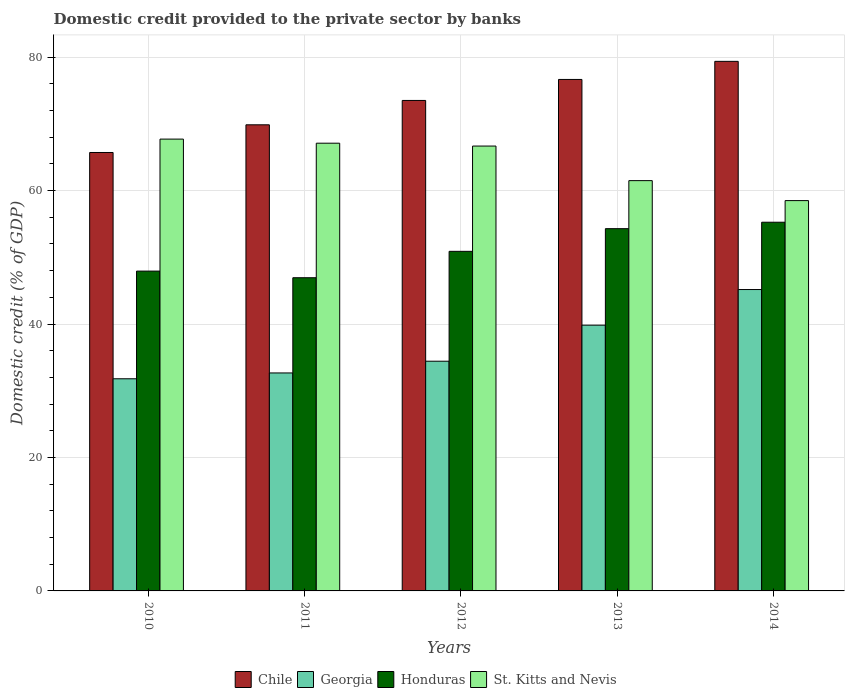How many different coloured bars are there?
Give a very brief answer. 4. How many groups of bars are there?
Ensure brevity in your answer.  5. Are the number of bars on each tick of the X-axis equal?
Ensure brevity in your answer.  Yes. How many bars are there on the 4th tick from the left?
Give a very brief answer. 4. How many bars are there on the 3rd tick from the right?
Keep it short and to the point. 4. In how many cases, is the number of bars for a given year not equal to the number of legend labels?
Offer a very short reply. 0. What is the domestic credit provided to the private sector by banks in Chile in 2012?
Offer a very short reply. 73.51. Across all years, what is the maximum domestic credit provided to the private sector by banks in Chile?
Provide a succinct answer. 79.37. Across all years, what is the minimum domestic credit provided to the private sector by banks in St. Kitts and Nevis?
Offer a terse response. 58.5. In which year was the domestic credit provided to the private sector by banks in Honduras maximum?
Make the answer very short. 2014. What is the total domestic credit provided to the private sector by banks in Chile in the graph?
Your response must be concise. 365.12. What is the difference between the domestic credit provided to the private sector by banks in Honduras in 2011 and that in 2013?
Give a very brief answer. -7.36. What is the difference between the domestic credit provided to the private sector by banks in Chile in 2011 and the domestic credit provided to the private sector by banks in Honduras in 2010?
Provide a short and direct response. 21.93. What is the average domestic credit provided to the private sector by banks in St. Kitts and Nevis per year?
Provide a succinct answer. 64.3. In the year 2013, what is the difference between the domestic credit provided to the private sector by banks in St. Kitts and Nevis and domestic credit provided to the private sector by banks in Chile?
Offer a terse response. -15.17. In how many years, is the domestic credit provided to the private sector by banks in Chile greater than 72 %?
Your answer should be compact. 3. What is the ratio of the domestic credit provided to the private sector by banks in Honduras in 2011 to that in 2012?
Your answer should be compact. 0.92. Is the domestic credit provided to the private sector by banks in St. Kitts and Nevis in 2010 less than that in 2012?
Your response must be concise. No. Is the difference between the domestic credit provided to the private sector by banks in St. Kitts and Nevis in 2011 and 2014 greater than the difference between the domestic credit provided to the private sector by banks in Chile in 2011 and 2014?
Make the answer very short. Yes. What is the difference between the highest and the second highest domestic credit provided to the private sector by banks in Georgia?
Your answer should be very brief. 5.34. What is the difference between the highest and the lowest domestic credit provided to the private sector by banks in Chile?
Provide a succinct answer. 13.66. Is it the case that in every year, the sum of the domestic credit provided to the private sector by banks in St. Kitts and Nevis and domestic credit provided to the private sector by banks in Georgia is greater than the sum of domestic credit provided to the private sector by banks in Honduras and domestic credit provided to the private sector by banks in Chile?
Ensure brevity in your answer.  No. What does the 4th bar from the left in 2014 represents?
Offer a very short reply. St. Kitts and Nevis. What does the 1st bar from the right in 2011 represents?
Keep it short and to the point. St. Kitts and Nevis. Is it the case that in every year, the sum of the domestic credit provided to the private sector by banks in Georgia and domestic credit provided to the private sector by banks in Honduras is greater than the domestic credit provided to the private sector by banks in St. Kitts and Nevis?
Ensure brevity in your answer.  Yes. How many bars are there?
Make the answer very short. 20. How many years are there in the graph?
Provide a short and direct response. 5. Does the graph contain any zero values?
Offer a terse response. No. What is the title of the graph?
Provide a short and direct response. Domestic credit provided to the private sector by banks. Does "Central African Republic" appear as one of the legend labels in the graph?
Provide a succinct answer. No. What is the label or title of the Y-axis?
Keep it short and to the point. Domestic credit (% of GDP). What is the Domestic credit (% of GDP) in Chile in 2010?
Give a very brief answer. 65.71. What is the Domestic credit (% of GDP) in Georgia in 2010?
Provide a succinct answer. 31.8. What is the Domestic credit (% of GDP) of Honduras in 2010?
Ensure brevity in your answer.  47.93. What is the Domestic credit (% of GDP) of St. Kitts and Nevis in 2010?
Your answer should be very brief. 67.72. What is the Domestic credit (% of GDP) in Chile in 2011?
Keep it short and to the point. 69.86. What is the Domestic credit (% of GDP) of Georgia in 2011?
Provide a short and direct response. 32.67. What is the Domestic credit (% of GDP) in Honduras in 2011?
Provide a succinct answer. 46.94. What is the Domestic credit (% of GDP) of St. Kitts and Nevis in 2011?
Ensure brevity in your answer.  67.1. What is the Domestic credit (% of GDP) of Chile in 2012?
Offer a very short reply. 73.51. What is the Domestic credit (% of GDP) in Georgia in 2012?
Your answer should be compact. 34.43. What is the Domestic credit (% of GDP) of Honduras in 2012?
Offer a very short reply. 50.9. What is the Domestic credit (% of GDP) of St. Kitts and Nevis in 2012?
Offer a very short reply. 66.68. What is the Domestic credit (% of GDP) of Chile in 2013?
Your answer should be very brief. 76.66. What is the Domestic credit (% of GDP) in Georgia in 2013?
Provide a succinct answer. 39.83. What is the Domestic credit (% of GDP) in Honduras in 2013?
Ensure brevity in your answer.  54.3. What is the Domestic credit (% of GDP) in St. Kitts and Nevis in 2013?
Provide a succinct answer. 61.49. What is the Domestic credit (% of GDP) in Chile in 2014?
Offer a terse response. 79.37. What is the Domestic credit (% of GDP) of Georgia in 2014?
Ensure brevity in your answer.  45.17. What is the Domestic credit (% of GDP) of Honduras in 2014?
Give a very brief answer. 55.26. What is the Domestic credit (% of GDP) in St. Kitts and Nevis in 2014?
Your answer should be compact. 58.5. Across all years, what is the maximum Domestic credit (% of GDP) in Chile?
Provide a short and direct response. 79.37. Across all years, what is the maximum Domestic credit (% of GDP) of Georgia?
Keep it short and to the point. 45.17. Across all years, what is the maximum Domestic credit (% of GDP) in Honduras?
Your answer should be compact. 55.26. Across all years, what is the maximum Domestic credit (% of GDP) of St. Kitts and Nevis?
Provide a short and direct response. 67.72. Across all years, what is the minimum Domestic credit (% of GDP) in Chile?
Provide a short and direct response. 65.71. Across all years, what is the minimum Domestic credit (% of GDP) of Georgia?
Provide a succinct answer. 31.8. Across all years, what is the minimum Domestic credit (% of GDP) in Honduras?
Your response must be concise. 46.94. Across all years, what is the minimum Domestic credit (% of GDP) in St. Kitts and Nevis?
Your answer should be very brief. 58.5. What is the total Domestic credit (% of GDP) of Chile in the graph?
Ensure brevity in your answer.  365.12. What is the total Domestic credit (% of GDP) in Georgia in the graph?
Keep it short and to the point. 183.9. What is the total Domestic credit (% of GDP) of Honduras in the graph?
Give a very brief answer. 255.33. What is the total Domestic credit (% of GDP) in St. Kitts and Nevis in the graph?
Give a very brief answer. 321.49. What is the difference between the Domestic credit (% of GDP) in Chile in 2010 and that in 2011?
Your answer should be very brief. -4.15. What is the difference between the Domestic credit (% of GDP) of Georgia in 2010 and that in 2011?
Make the answer very short. -0.87. What is the difference between the Domestic credit (% of GDP) of St. Kitts and Nevis in 2010 and that in 2011?
Your answer should be very brief. 0.61. What is the difference between the Domestic credit (% of GDP) in Chile in 2010 and that in 2012?
Ensure brevity in your answer.  -7.8. What is the difference between the Domestic credit (% of GDP) in Georgia in 2010 and that in 2012?
Your answer should be very brief. -2.63. What is the difference between the Domestic credit (% of GDP) in Honduras in 2010 and that in 2012?
Offer a terse response. -2.96. What is the difference between the Domestic credit (% of GDP) of St. Kitts and Nevis in 2010 and that in 2012?
Offer a terse response. 1.04. What is the difference between the Domestic credit (% of GDP) of Chile in 2010 and that in 2013?
Keep it short and to the point. -10.95. What is the difference between the Domestic credit (% of GDP) of Georgia in 2010 and that in 2013?
Your answer should be very brief. -8.04. What is the difference between the Domestic credit (% of GDP) of Honduras in 2010 and that in 2013?
Make the answer very short. -6.36. What is the difference between the Domestic credit (% of GDP) of St. Kitts and Nevis in 2010 and that in 2013?
Offer a very short reply. 6.22. What is the difference between the Domestic credit (% of GDP) in Chile in 2010 and that in 2014?
Offer a terse response. -13.66. What is the difference between the Domestic credit (% of GDP) in Georgia in 2010 and that in 2014?
Your response must be concise. -13.37. What is the difference between the Domestic credit (% of GDP) of Honduras in 2010 and that in 2014?
Provide a succinct answer. -7.33. What is the difference between the Domestic credit (% of GDP) of St. Kitts and Nevis in 2010 and that in 2014?
Your response must be concise. 9.22. What is the difference between the Domestic credit (% of GDP) of Chile in 2011 and that in 2012?
Provide a short and direct response. -3.65. What is the difference between the Domestic credit (% of GDP) of Georgia in 2011 and that in 2012?
Your answer should be compact. -1.76. What is the difference between the Domestic credit (% of GDP) in Honduras in 2011 and that in 2012?
Provide a succinct answer. -3.96. What is the difference between the Domestic credit (% of GDP) of St. Kitts and Nevis in 2011 and that in 2012?
Ensure brevity in your answer.  0.43. What is the difference between the Domestic credit (% of GDP) in Chile in 2011 and that in 2013?
Offer a very short reply. -6.8. What is the difference between the Domestic credit (% of GDP) in Georgia in 2011 and that in 2013?
Keep it short and to the point. -7.16. What is the difference between the Domestic credit (% of GDP) in Honduras in 2011 and that in 2013?
Your answer should be compact. -7.36. What is the difference between the Domestic credit (% of GDP) of St. Kitts and Nevis in 2011 and that in 2013?
Make the answer very short. 5.61. What is the difference between the Domestic credit (% of GDP) of Chile in 2011 and that in 2014?
Offer a very short reply. -9.51. What is the difference between the Domestic credit (% of GDP) of Georgia in 2011 and that in 2014?
Make the answer very short. -12.5. What is the difference between the Domestic credit (% of GDP) of Honduras in 2011 and that in 2014?
Make the answer very short. -8.32. What is the difference between the Domestic credit (% of GDP) of St. Kitts and Nevis in 2011 and that in 2014?
Your answer should be very brief. 8.6. What is the difference between the Domestic credit (% of GDP) of Chile in 2012 and that in 2013?
Your response must be concise. -3.15. What is the difference between the Domestic credit (% of GDP) in Georgia in 2012 and that in 2013?
Your response must be concise. -5.4. What is the difference between the Domestic credit (% of GDP) of Honduras in 2012 and that in 2013?
Offer a very short reply. -3.4. What is the difference between the Domestic credit (% of GDP) in St. Kitts and Nevis in 2012 and that in 2013?
Give a very brief answer. 5.18. What is the difference between the Domestic credit (% of GDP) of Chile in 2012 and that in 2014?
Your answer should be compact. -5.86. What is the difference between the Domestic credit (% of GDP) of Georgia in 2012 and that in 2014?
Keep it short and to the point. -10.74. What is the difference between the Domestic credit (% of GDP) in Honduras in 2012 and that in 2014?
Offer a very short reply. -4.36. What is the difference between the Domestic credit (% of GDP) in St. Kitts and Nevis in 2012 and that in 2014?
Provide a short and direct response. 8.18. What is the difference between the Domestic credit (% of GDP) of Chile in 2013 and that in 2014?
Your response must be concise. -2.71. What is the difference between the Domestic credit (% of GDP) of Georgia in 2013 and that in 2014?
Offer a very short reply. -5.34. What is the difference between the Domestic credit (% of GDP) in Honduras in 2013 and that in 2014?
Your answer should be very brief. -0.96. What is the difference between the Domestic credit (% of GDP) of St. Kitts and Nevis in 2013 and that in 2014?
Keep it short and to the point. 2.99. What is the difference between the Domestic credit (% of GDP) in Chile in 2010 and the Domestic credit (% of GDP) in Georgia in 2011?
Ensure brevity in your answer.  33.04. What is the difference between the Domestic credit (% of GDP) in Chile in 2010 and the Domestic credit (% of GDP) in Honduras in 2011?
Offer a very short reply. 18.77. What is the difference between the Domestic credit (% of GDP) in Chile in 2010 and the Domestic credit (% of GDP) in St. Kitts and Nevis in 2011?
Ensure brevity in your answer.  -1.39. What is the difference between the Domestic credit (% of GDP) in Georgia in 2010 and the Domestic credit (% of GDP) in Honduras in 2011?
Offer a terse response. -15.14. What is the difference between the Domestic credit (% of GDP) in Georgia in 2010 and the Domestic credit (% of GDP) in St. Kitts and Nevis in 2011?
Your response must be concise. -35.31. What is the difference between the Domestic credit (% of GDP) in Honduras in 2010 and the Domestic credit (% of GDP) in St. Kitts and Nevis in 2011?
Make the answer very short. -19.17. What is the difference between the Domestic credit (% of GDP) of Chile in 2010 and the Domestic credit (% of GDP) of Georgia in 2012?
Offer a terse response. 31.28. What is the difference between the Domestic credit (% of GDP) of Chile in 2010 and the Domestic credit (% of GDP) of Honduras in 2012?
Provide a short and direct response. 14.81. What is the difference between the Domestic credit (% of GDP) of Chile in 2010 and the Domestic credit (% of GDP) of St. Kitts and Nevis in 2012?
Ensure brevity in your answer.  -0.96. What is the difference between the Domestic credit (% of GDP) of Georgia in 2010 and the Domestic credit (% of GDP) of Honduras in 2012?
Keep it short and to the point. -19.1. What is the difference between the Domestic credit (% of GDP) in Georgia in 2010 and the Domestic credit (% of GDP) in St. Kitts and Nevis in 2012?
Keep it short and to the point. -34.88. What is the difference between the Domestic credit (% of GDP) in Honduras in 2010 and the Domestic credit (% of GDP) in St. Kitts and Nevis in 2012?
Keep it short and to the point. -18.74. What is the difference between the Domestic credit (% of GDP) in Chile in 2010 and the Domestic credit (% of GDP) in Georgia in 2013?
Your answer should be compact. 25.88. What is the difference between the Domestic credit (% of GDP) of Chile in 2010 and the Domestic credit (% of GDP) of Honduras in 2013?
Your answer should be compact. 11.42. What is the difference between the Domestic credit (% of GDP) in Chile in 2010 and the Domestic credit (% of GDP) in St. Kitts and Nevis in 2013?
Offer a terse response. 4.22. What is the difference between the Domestic credit (% of GDP) of Georgia in 2010 and the Domestic credit (% of GDP) of Honduras in 2013?
Offer a terse response. -22.5. What is the difference between the Domestic credit (% of GDP) in Georgia in 2010 and the Domestic credit (% of GDP) in St. Kitts and Nevis in 2013?
Make the answer very short. -29.7. What is the difference between the Domestic credit (% of GDP) of Honduras in 2010 and the Domestic credit (% of GDP) of St. Kitts and Nevis in 2013?
Offer a very short reply. -13.56. What is the difference between the Domestic credit (% of GDP) in Chile in 2010 and the Domestic credit (% of GDP) in Georgia in 2014?
Ensure brevity in your answer.  20.54. What is the difference between the Domestic credit (% of GDP) in Chile in 2010 and the Domestic credit (% of GDP) in Honduras in 2014?
Offer a terse response. 10.45. What is the difference between the Domestic credit (% of GDP) in Chile in 2010 and the Domestic credit (% of GDP) in St. Kitts and Nevis in 2014?
Ensure brevity in your answer.  7.21. What is the difference between the Domestic credit (% of GDP) of Georgia in 2010 and the Domestic credit (% of GDP) of Honduras in 2014?
Your answer should be very brief. -23.46. What is the difference between the Domestic credit (% of GDP) of Georgia in 2010 and the Domestic credit (% of GDP) of St. Kitts and Nevis in 2014?
Offer a very short reply. -26.7. What is the difference between the Domestic credit (% of GDP) in Honduras in 2010 and the Domestic credit (% of GDP) in St. Kitts and Nevis in 2014?
Offer a very short reply. -10.57. What is the difference between the Domestic credit (% of GDP) in Chile in 2011 and the Domestic credit (% of GDP) in Georgia in 2012?
Make the answer very short. 35.43. What is the difference between the Domestic credit (% of GDP) in Chile in 2011 and the Domestic credit (% of GDP) in Honduras in 2012?
Give a very brief answer. 18.96. What is the difference between the Domestic credit (% of GDP) of Chile in 2011 and the Domestic credit (% of GDP) of St. Kitts and Nevis in 2012?
Provide a succinct answer. 3.19. What is the difference between the Domestic credit (% of GDP) in Georgia in 2011 and the Domestic credit (% of GDP) in Honduras in 2012?
Offer a very short reply. -18.23. What is the difference between the Domestic credit (% of GDP) in Georgia in 2011 and the Domestic credit (% of GDP) in St. Kitts and Nevis in 2012?
Make the answer very short. -34.01. What is the difference between the Domestic credit (% of GDP) in Honduras in 2011 and the Domestic credit (% of GDP) in St. Kitts and Nevis in 2012?
Your answer should be very brief. -19.74. What is the difference between the Domestic credit (% of GDP) in Chile in 2011 and the Domestic credit (% of GDP) in Georgia in 2013?
Offer a terse response. 30.03. What is the difference between the Domestic credit (% of GDP) in Chile in 2011 and the Domestic credit (% of GDP) in Honduras in 2013?
Provide a short and direct response. 15.57. What is the difference between the Domestic credit (% of GDP) in Chile in 2011 and the Domestic credit (% of GDP) in St. Kitts and Nevis in 2013?
Provide a succinct answer. 8.37. What is the difference between the Domestic credit (% of GDP) of Georgia in 2011 and the Domestic credit (% of GDP) of Honduras in 2013?
Keep it short and to the point. -21.62. What is the difference between the Domestic credit (% of GDP) in Georgia in 2011 and the Domestic credit (% of GDP) in St. Kitts and Nevis in 2013?
Your answer should be compact. -28.82. What is the difference between the Domestic credit (% of GDP) of Honduras in 2011 and the Domestic credit (% of GDP) of St. Kitts and Nevis in 2013?
Your response must be concise. -14.55. What is the difference between the Domestic credit (% of GDP) of Chile in 2011 and the Domestic credit (% of GDP) of Georgia in 2014?
Keep it short and to the point. 24.69. What is the difference between the Domestic credit (% of GDP) in Chile in 2011 and the Domestic credit (% of GDP) in Honduras in 2014?
Ensure brevity in your answer.  14.6. What is the difference between the Domestic credit (% of GDP) in Chile in 2011 and the Domestic credit (% of GDP) in St. Kitts and Nevis in 2014?
Make the answer very short. 11.36. What is the difference between the Domestic credit (% of GDP) of Georgia in 2011 and the Domestic credit (% of GDP) of Honduras in 2014?
Your response must be concise. -22.59. What is the difference between the Domestic credit (% of GDP) in Georgia in 2011 and the Domestic credit (% of GDP) in St. Kitts and Nevis in 2014?
Offer a terse response. -25.83. What is the difference between the Domestic credit (% of GDP) in Honduras in 2011 and the Domestic credit (% of GDP) in St. Kitts and Nevis in 2014?
Ensure brevity in your answer.  -11.56. What is the difference between the Domestic credit (% of GDP) of Chile in 2012 and the Domestic credit (% of GDP) of Georgia in 2013?
Keep it short and to the point. 33.68. What is the difference between the Domestic credit (% of GDP) in Chile in 2012 and the Domestic credit (% of GDP) in Honduras in 2013?
Provide a short and direct response. 19.22. What is the difference between the Domestic credit (% of GDP) in Chile in 2012 and the Domestic credit (% of GDP) in St. Kitts and Nevis in 2013?
Make the answer very short. 12.02. What is the difference between the Domestic credit (% of GDP) of Georgia in 2012 and the Domestic credit (% of GDP) of Honduras in 2013?
Ensure brevity in your answer.  -19.87. What is the difference between the Domestic credit (% of GDP) in Georgia in 2012 and the Domestic credit (% of GDP) in St. Kitts and Nevis in 2013?
Keep it short and to the point. -27.06. What is the difference between the Domestic credit (% of GDP) in Honduras in 2012 and the Domestic credit (% of GDP) in St. Kitts and Nevis in 2013?
Keep it short and to the point. -10.6. What is the difference between the Domestic credit (% of GDP) in Chile in 2012 and the Domestic credit (% of GDP) in Georgia in 2014?
Make the answer very short. 28.34. What is the difference between the Domestic credit (% of GDP) of Chile in 2012 and the Domestic credit (% of GDP) of Honduras in 2014?
Your response must be concise. 18.25. What is the difference between the Domestic credit (% of GDP) of Chile in 2012 and the Domestic credit (% of GDP) of St. Kitts and Nevis in 2014?
Keep it short and to the point. 15.01. What is the difference between the Domestic credit (% of GDP) in Georgia in 2012 and the Domestic credit (% of GDP) in Honduras in 2014?
Provide a short and direct response. -20.83. What is the difference between the Domestic credit (% of GDP) of Georgia in 2012 and the Domestic credit (% of GDP) of St. Kitts and Nevis in 2014?
Keep it short and to the point. -24.07. What is the difference between the Domestic credit (% of GDP) in Honduras in 2012 and the Domestic credit (% of GDP) in St. Kitts and Nevis in 2014?
Make the answer very short. -7.6. What is the difference between the Domestic credit (% of GDP) in Chile in 2013 and the Domestic credit (% of GDP) in Georgia in 2014?
Ensure brevity in your answer.  31.49. What is the difference between the Domestic credit (% of GDP) in Chile in 2013 and the Domestic credit (% of GDP) in Honduras in 2014?
Offer a terse response. 21.4. What is the difference between the Domestic credit (% of GDP) in Chile in 2013 and the Domestic credit (% of GDP) in St. Kitts and Nevis in 2014?
Your answer should be very brief. 18.16. What is the difference between the Domestic credit (% of GDP) of Georgia in 2013 and the Domestic credit (% of GDP) of Honduras in 2014?
Offer a very short reply. -15.43. What is the difference between the Domestic credit (% of GDP) in Georgia in 2013 and the Domestic credit (% of GDP) in St. Kitts and Nevis in 2014?
Ensure brevity in your answer.  -18.67. What is the difference between the Domestic credit (% of GDP) in Honduras in 2013 and the Domestic credit (% of GDP) in St. Kitts and Nevis in 2014?
Your answer should be compact. -4.2. What is the average Domestic credit (% of GDP) of Chile per year?
Provide a short and direct response. 73.02. What is the average Domestic credit (% of GDP) in Georgia per year?
Offer a terse response. 36.78. What is the average Domestic credit (% of GDP) in Honduras per year?
Offer a very short reply. 51.07. What is the average Domestic credit (% of GDP) of St. Kitts and Nevis per year?
Provide a succinct answer. 64.3. In the year 2010, what is the difference between the Domestic credit (% of GDP) in Chile and Domestic credit (% of GDP) in Georgia?
Your answer should be very brief. 33.92. In the year 2010, what is the difference between the Domestic credit (% of GDP) of Chile and Domestic credit (% of GDP) of Honduras?
Your answer should be compact. 17.78. In the year 2010, what is the difference between the Domestic credit (% of GDP) of Chile and Domestic credit (% of GDP) of St. Kitts and Nevis?
Keep it short and to the point. -2.01. In the year 2010, what is the difference between the Domestic credit (% of GDP) in Georgia and Domestic credit (% of GDP) in Honduras?
Your answer should be very brief. -16.14. In the year 2010, what is the difference between the Domestic credit (% of GDP) in Georgia and Domestic credit (% of GDP) in St. Kitts and Nevis?
Give a very brief answer. -35.92. In the year 2010, what is the difference between the Domestic credit (% of GDP) of Honduras and Domestic credit (% of GDP) of St. Kitts and Nevis?
Your answer should be very brief. -19.78. In the year 2011, what is the difference between the Domestic credit (% of GDP) in Chile and Domestic credit (% of GDP) in Georgia?
Offer a terse response. 37.19. In the year 2011, what is the difference between the Domestic credit (% of GDP) of Chile and Domestic credit (% of GDP) of Honduras?
Give a very brief answer. 22.92. In the year 2011, what is the difference between the Domestic credit (% of GDP) in Chile and Domestic credit (% of GDP) in St. Kitts and Nevis?
Keep it short and to the point. 2.76. In the year 2011, what is the difference between the Domestic credit (% of GDP) in Georgia and Domestic credit (% of GDP) in Honduras?
Provide a succinct answer. -14.27. In the year 2011, what is the difference between the Domestic credit (% of GDP) of Georgia and Domestic credit (% of GDP) of St. Kitts and Nevis?
Give a very brief answer. -34.43. In the year 2011, what is the difference between the Domestic credit (% of GDP) in Honduras and Domestic credit (% of GDP) in St. Kitts and Nevis?
Your response must be concise. -20.16. In the year 2012, what is the difference between the Domestic credit (% of GDP) of Chile and Domestic credit (% of GDP) of Georgia?
Keep it short and to the point. 39.08. In the year 2012, what is the difference between the Domestic credit (% of GDP) in Chile and Domestic credit (% of GDP) in Honduras?
Ensure brevity in your answer.  22.61. In the year 2012, what is the difference between the Domestic credit (% of GDP) of Chile and Domestic credit (% of GDP) of St. Kitts and Nevis?
Make the answer very short. 6.84. In the year 2012, what is the difference between the Domestic credit (% of GDP) in Georgia and Domestic credit (% of GDP) in Honduras?
Provide a short and direct response. -16.47. In the year 2012, what is the difference between the Domestic credit (% of GDP) of Georgia and Domestic credit (% of GDP) of St. Kitts and Nevis?
Offer a very short reply. -32.25. In the year 2012, what is the difference between the Domestic credit (% of GDP) in Honduras and Domestic credit (% of GDP) in St. Kitts and Nevis?
Your answer should be compact. -15.78. In the year 2013, what is the difference between the Domestic credit (% of GDP) of Chile and Domestic credit (% of GDP) of Georgia?
Your response must be concise. 36.83. In the year 2013, what is the difference between the Domestic credit (% of GDP) in Chile and Domestic credit (% of GDP) in Honduras?
Ensure brevity in your answer.  22.36. In the year 2013, what is the difference between the Domestic credit (% of GDP) of Chile and Domestic credit (% of GDP) of St. Kitts and Nevis?
Your answer should be very brief. 15.17. In the year 2013, what is the difference between the Domestic credit (% of GDP) of Georgia and Domestic credit (% of GDP) of Honduras?
Give a very brief answer. -14.46. In the year 2013, what is the difference between the Domestic credit (% of GDP) of Georgia and Domestic credit (% of GDP) of St. Kitts and Nevis?
Your response must be concise. -21.66. In the year 2013, what is the difference between the Domestic credit (% of GDP) in Honduras and Domestic credit (% of GDP) in St. Kitts and Nevis?
Your answer should be very brief. -7.2. In the year 2014, what is the difference between the Domestic credit (% of GDP) in Chile and Domestic credit (% of GDP) in Georgia?
Give a very brief answer. 34.2. In the year 2014, what is the difference between the Domestic credit (% of GDP) in Chile and Domestic credit (% of GDP) in Honduras?
Offer a terse response. 24.11. In the year 2014, what is the difference between the Domestic credit (% of GDP) in Chile and Domestic credit (% of GDP) in St. Kitts and Nevis?
Provide a succinct answer. 20.87. In the year 2014, what is the difference between the Domestic credit (% of GDP) in Georgia and Domestic credit (% of GDP) in Honduras?
Offer a terse response. -10.09. In the year 2014, what is the difference between the Domestic credit (% of GDP) of Georgia and Domestic credit (% of GDP) of St. Kitts and Nevis?
Your answer should be very brief. -13.33. In the year 2014, what is the difference between the Domestic credit (% of GDP) of Honduras and Domestic credit (% of GDP) of St. Kitts and Nevis?
Keep it short and to the point. -3.24. What is the ratio of the Domestic credit (% of GDP) of Chile in 2010 to that in 2011?
Give a very brief answer. 0.94. What is the ratio of the Domestic credit (% of GDP) in Georgia in 2010 to that in 2011?
Provide a succinct answer. 0.97. What is the ratio of the Domestic credit (% of GDP) in Honduras in 2010 to that in 2011?
Your answer should be very brief. 1.02. What is the ratio of the Domestic credit (% of GDP) of St. Kitts and Nevis in 2010 to that in 2011?
Offer a terse response. 1.01. What is the ratio of the Domestic credit (% of GDP) in Chile in 2010 to that in 2012?
Offer a terse response. 0.89. What is the ratio of the Domestic credit (% of GDP) in Georgia in 2010 to that in 2012?
Your response must be concise. 0.92. What is the ratio of the Domestic credit (% of GDP) of Honduras in 2010 to that in 2012?
Offer a very short reply. 0.94. What is the ratio of the Domestic credit (% of GDP) in St. Kitts and Nevis in 2010 to that in 2012?
Your answer should be very brief. 1.02. What is the ratio of the Domestic credit (% of GDP) in Chile in 2010 to that in 2013?
Your answer should be compact. 0.86. What is the ratio of the Domestic credit (% of GDP) of Georgia in 2010 to that in 2013?
Make the answer very short. 0.8. What is the ratio of the Domestic credit (% of GDP) of Honduras in 2010 to that in 2013?
Your answer should be very brief. 0.88. What is the ratio of the Domestic credit (% of GDP) in St. Kitts and Nevis in 2010 to that in 2013?
Make the answer very short. 1.1. What is the ratio of the Domestic credit (% of GDP) of Chile in 2010 to that in 2014?
Offer a terse response. 0.83. What is the ratio of the Domestic credit (% of GDP) of Georgia in 2010 to that in 2014?
Your answer should be very brief. 0.7. What is the ratio of the Domestic credit (% of GDP) in Honduras in 2010 to that in 2014?
Your answer should be compact. 0.87. What is the ratio of the Domestic credit (% of GDP) in St. Kitts and Nevis in 2010 to that in 2014?
Your response must be concise. 1.16. What is the ratio of the Domestic credit (% of GDP) of Chile in 2011 to that in 2012?
Provide a succinct answer. 0.95. What is the ratio of the Domestic credit (% of GDP) in Georgia in 2011 to that in 2012?
Provide a short and direct response. 0.95. What is the ratio of the Domestic credit (% of GDP) in Honduras in 2011 to that in 2012?
Make the answer very short. 0.92. What is the ratio of the Domestic credit (% of GDP) of St. Kitts and Nevis in 2011 to that in 2012?
Your answer should be very brief. 1.01. What is the ratio of the Domestic credit (% of GDP) of Chile in 2011 to that in 2013?
Provide a short and direct response. 0.91. What is the ratio of the Domestic credit (% of GDP) of Georgia in 2011 to that in 2013?
Your answer should be compact. 0.82. What is the ratio of the Domestic credit (% of GDP) in Honduras in 2011 to that in 2013?
Make the answer very short. 0.86. What is the ratio of the Domestic credit (% of GDP) of St. Kitts and Nevis in 2011 to that in 2013?
Your answer should be compact. 1.09. What is the ratio of the Domestic credit (% of GDP) in Chile in 2011 to that in 2014?
Ensure brevity in your answer.  0.88. What is the ratio of the Domestic credit (% of GDP) of Georgia in 2011 to that in 2014?
Your answer should be very brief. 0.72. What is the ratio of the Domestic credit (% of GDP) in Honduras in 2011 to that in 2014?
Provide a succinct answer. 0.85. What is the ratio of the Domestic credit (% of GDP) of St. Kitts and Nevis in 2011 to that in 2014?
Ensure brevity in your answer.  1.15. What is the ratio of the Domestic credit (% of GDP) of Chile in 2012 to that in 2013?
Offer a terse response. 0.96. What is the ratio of the Domestic credit (% of GDP) of Georgia in 2012 to that in 2013?
Your response must be concise. 0.86. What is the ratio of the Domestic credit (% of GDP) in Honduras in 2012 to that in 2013?
Your response must be concise. 0.94. What is the ratio of the Domestic credit (% of GDP) in St. Kitts and Nevis in 2012 to that in 2013?
Make the answer very short. 1.08. What is the ratio of the Domestic credit (% of GDP) of Chile in 2012 to that in 2014?
Provide a succinct answer. 0.93. What is the ratio of the Domestic credit (% of GDP) of Georgia in 2012 to that in 2014?
Your response must be concise. 0.76. What is the ratio of the Domestic credit (% of GDP) of Honduras in 2012 to that in 2014?
Offer a very short reply. 0.92. What is the ratio of the Domestic credit (% of GDP) of St. Kitts and Nevis in 2012 to that in 2014?
Offer a very short reply. 1.14. What is the ratio of the Domestic credit (% of GDP) in Chile in 2013 to that in 2014?
Offer a very short reply. 0.97. What is the ratio of the Domestic credit (% of GDP) of Georgia in 2013 to that in 2014?
Keep it short and to the point. 0.88. What is the ratio of the Domestic credit (% of GDP) in Honduras in 2013 to that in 2014?
Your response must be concise. 0.98. What is the ratio of the Domestic credit (% of GDP) of St. Kitts and Nevis in 2013 to that in 2014?
Your answer should be very brief. 1.05. What is the difference between the highest and the second highest Domestic credit (% of GDP) in Chile?
Offer a terse response. 2.71. What is the difference between the highest and the second highest Domestic credit (% of GDP) in Georgia?
Ensure brevity in your answer.  5.34. What is the difference between the highest and the second highest Domestic credit (% of GDP) in Honduras?
Offer a terse response. 0.96. What is the difference between the highest and the second highest Domestic credit (% of GDP) in St. Kitts and Nevis?
Offer a terse response. 0.61. What is the difference between the highest and the lowest Domestic credit (% of GDP) of Chile?
Your answer should be compact. 13.66. What is the difference between the highest and the lowest Domestic credit (% of GDP) of Georgia?
Provide a succinct answer. 13.37. What is the difference between the highest and the lowest Domestic credit (% of GDP) in Honduras?
Your answer should be very brief. 8.32. What is the difference between the highest and the lowest Domestic credit (% of GDP) of St. Kitts and Nevis?
Keep it short and to the point. 9.22. 